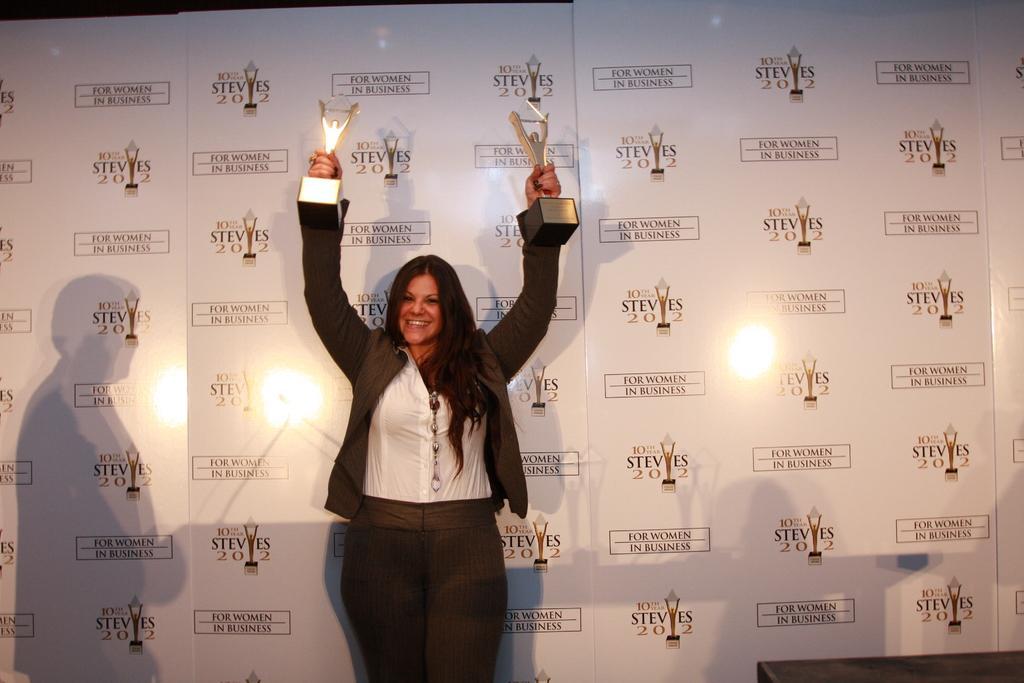In one or two sentences, can you explain what this image depicts? In the picture we can see a woman standing and holding two awards in her hands and raising it and she is in black color blazer, white shirt and behind her we can see a banner with some brand symbols on it. 